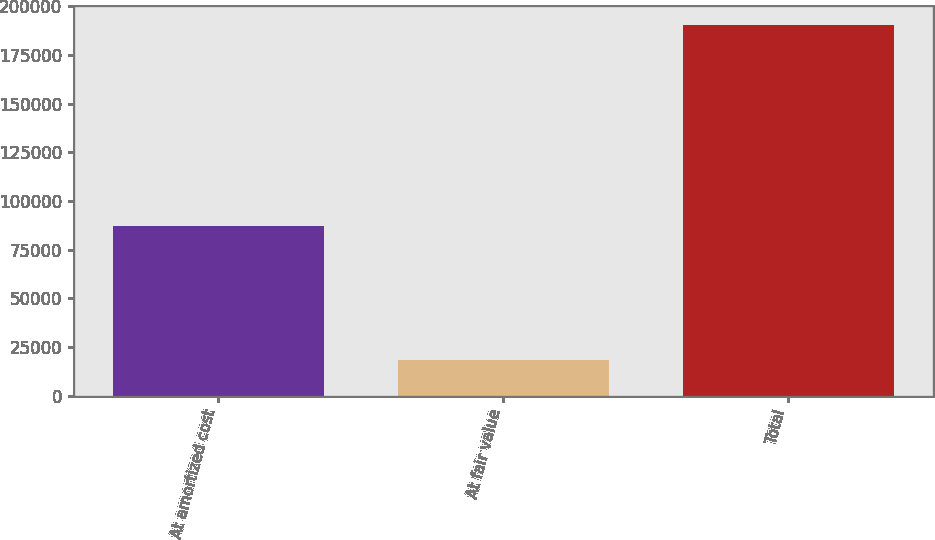Convert chart to OTSL. <chart><loc_0><loc_0><loc_500><loc_500><bar_chart><fcel>At amortized cost<fcel>At fair value<fcel>Total<nl><fcel>86951<fcel>18207<fcel>190482<nl></chart> 